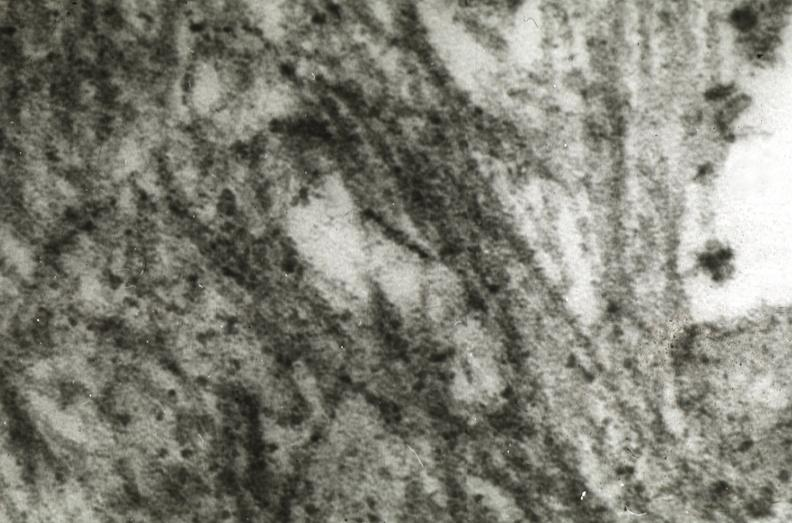does muscle atrophy show amyloidosis?
Answer the question using a single word or phrase. No 